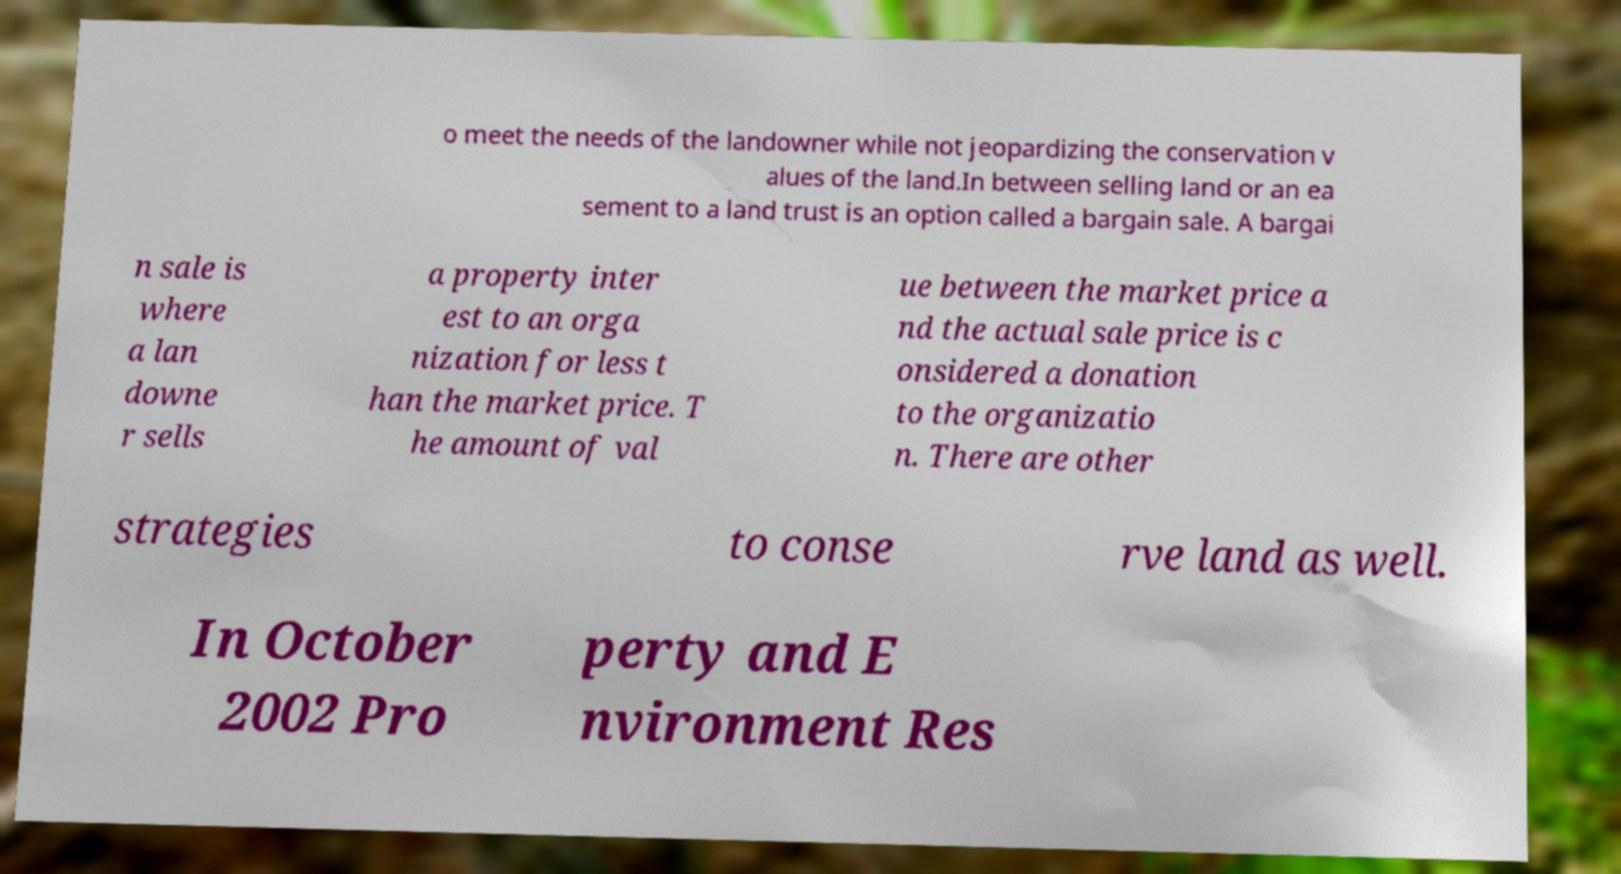Can you accurately transcribe the text from the provided image for me? o meet the needs of the landowner while not jeopardizing the conservation v alues of the land.In between selling land or an ea sement to a land trust is an option called a bargain sale. A bargai n sale is where a lan downe r sells a property inter est to an orga nization for less t han the market price. T he amount of val ue between the market price a nd the actual sale price is c onsidered a donation to the organizatio n. There are other strategies to conse rve land as well. In October 2002 Pro perty and E nvironment Res 